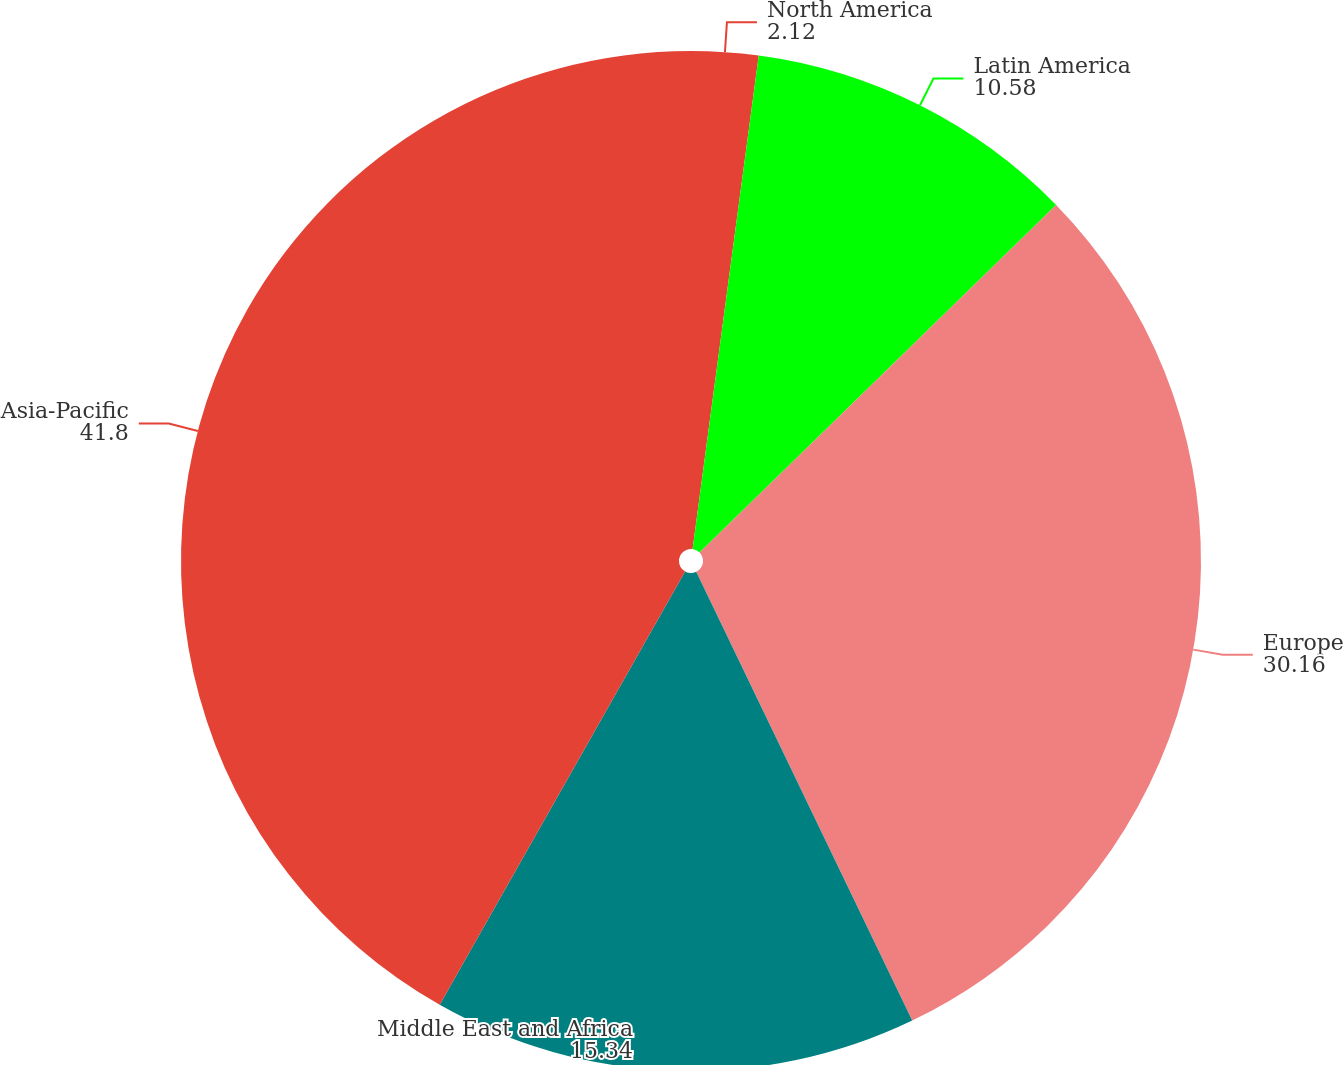Convert chart to OTSL. <chart><loc_0><loc_0><loc_500><loc_500><pie_chart><fcel>North America<fcel>Latin America<fcel>Europe<fcel>Middle East and Africa<fcel>Asia-Pacific<nl><fcel>2.12%<fcel>10.58%<fcel>30.16%<fcel>15.34%<fcel>41.8%<nl></chart> 